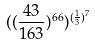Convert formula to latex. <formula><loc_0><loc_0><loc_500><loc_500>( ( \frac { 4 3 } { 1 6 3 } ) ^ { 6 6 } ) ^ { ( \frac { 1 } { 3 } ) ^ { 7 } }</formula> 